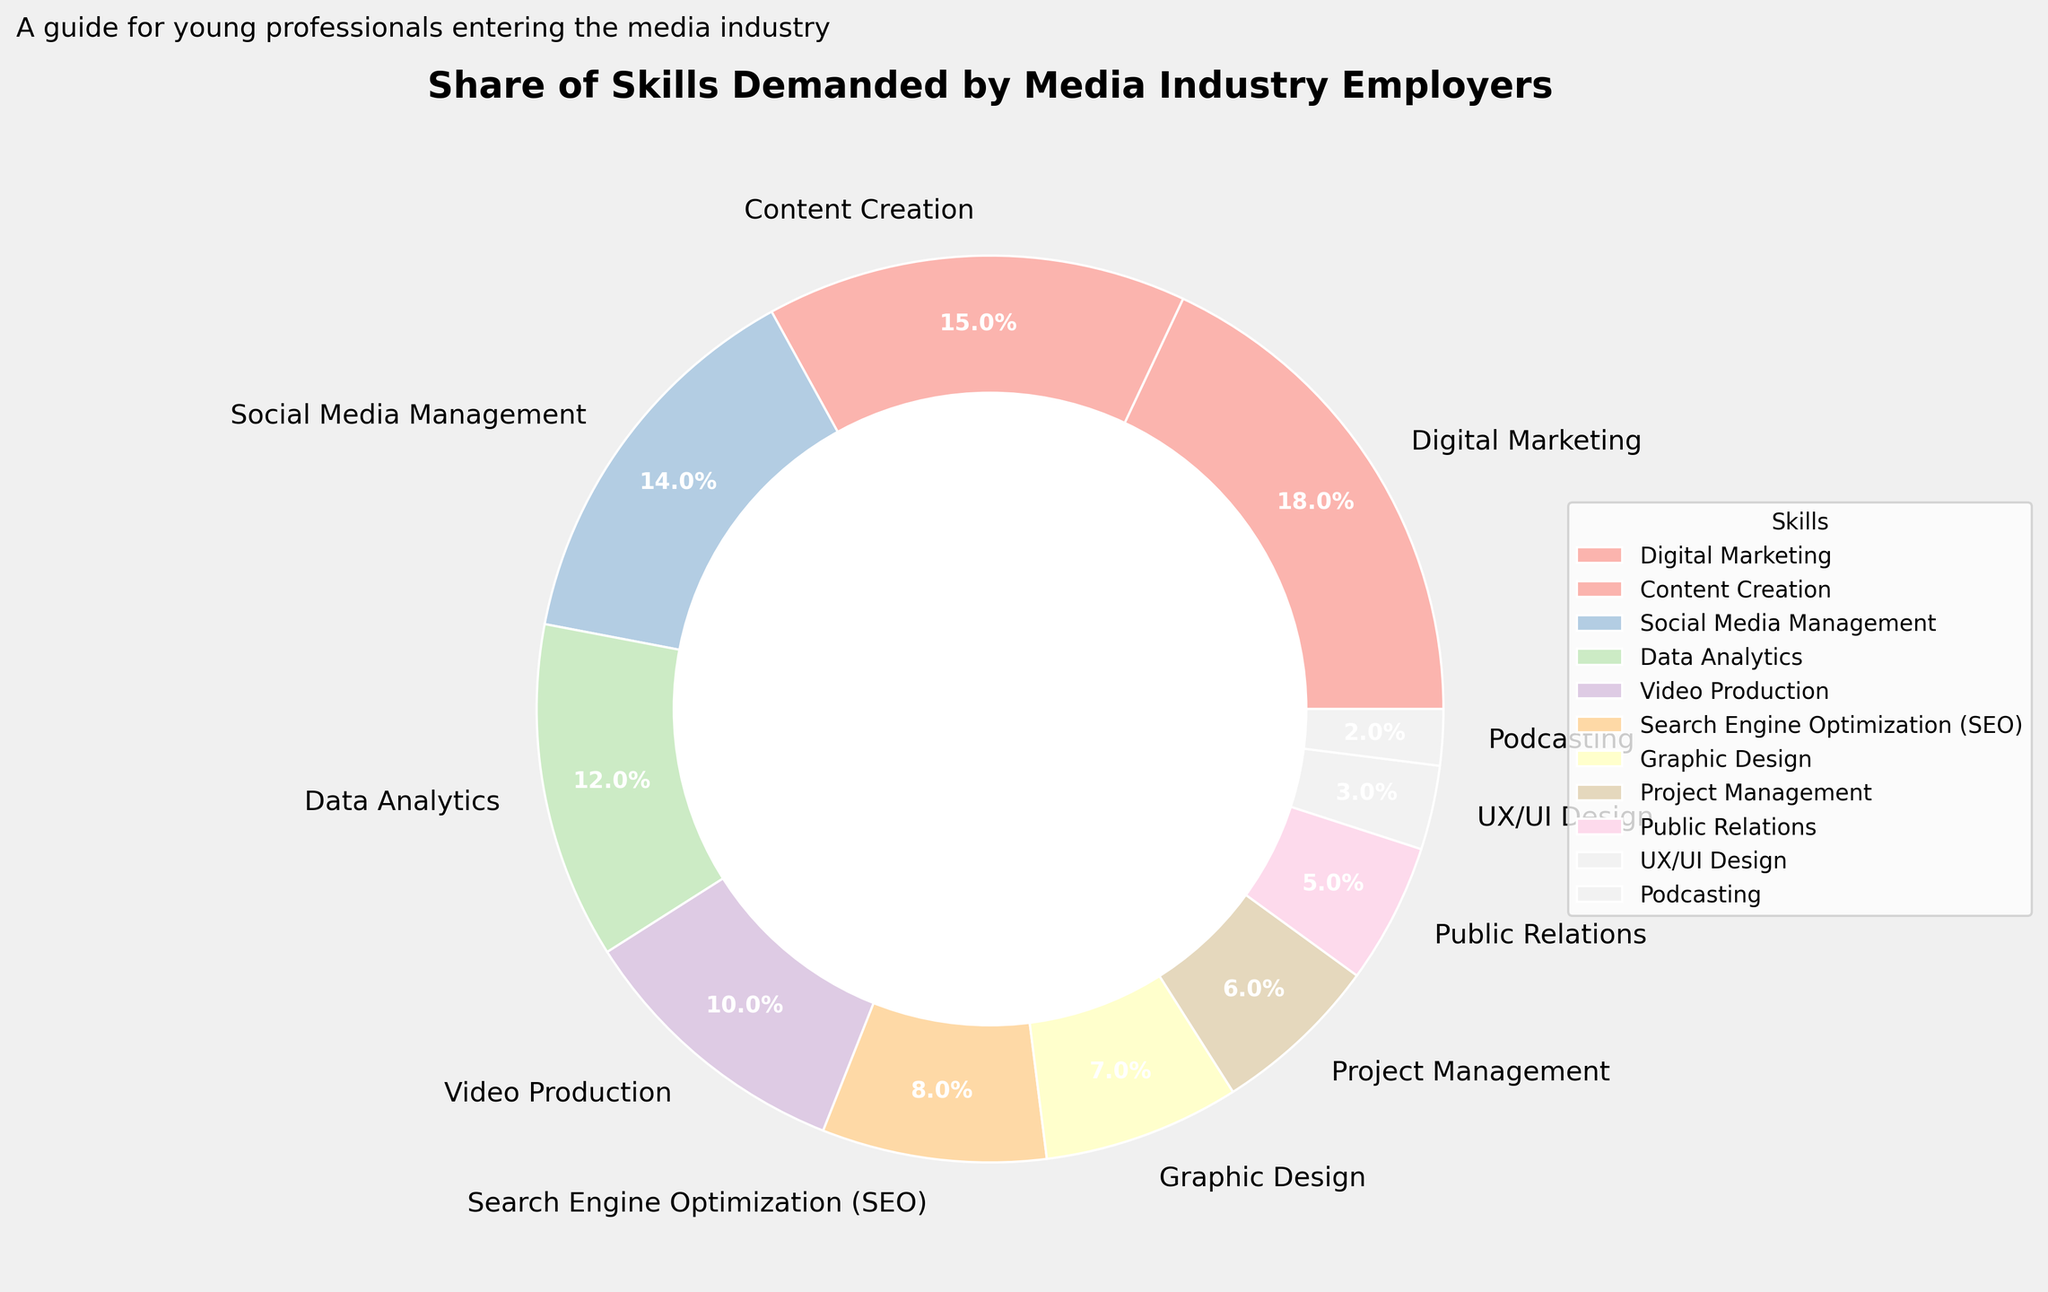What is the largest skill set demanded by media industry employers? The largest segment in the pie chart represents Digital Marketing which occupies the highest percentage among all skill sets.
Answer: Digital Marketing Which skill set has the smallest share according to the pie chart? The smallest slice of the pie chart corresponds to Podcasting, which has the lowest percentage among the listed skill sets.
Answer: Podcasting Compare the demand for Social Media Management and SEO. Which one is more in demand? By examining the pie chart, Social Media Management has a larger segment than Search Engine Optimization (SEO), indicating a higher demand.
Answer: Social Media Management What is the combined percentage of Content Creation and Video Production? The percentage for Content Creation is 15%, and for Video Production, it is 10%. Adding these together, the combined percentage is 25%.
Answer: 25% How much greater is the demand for Data Analytics compared to UX/UI Design? The demand for Data Analytics is 12%, and for UX/UI Design, it is 3%. Subtracting these values, Data Analytics is 9% more in demand than UX/UI Design.
Answer: 9% Is Graphic Design in higher demand than Public Relations based on the chart? By looking at the pie chart, Graphic Design covers a larger percentage area (7%) compared to Public Relations (5%).
Answer: Yes What is the aggregate demand for the top three skills? The top three skills by percentage are Digital Marketing (18%), Content Creation (15%), and Social Media Management (14%). Summing these gives an aggregate demand of 47%.
Answer: 47% How does the demand for Project Management compare to the demand for UX/UI Design and Public Relations combined? Project Management has a demand of 6%. UX/UI Design and Public Relations combined have a demand of (3% + 5% = 8%). Therefore, the combined demand for UX/UI Design and Public Relations is greater by 2%.
Answer: Combined demand for UX/UI Design and Public Relations is greater Which skills together make up exactly one-third of the total demand? Digital Marketing (18%) and Video Production (10%) together make up 28%. Including Public Relations (5%) sums to 33%. Therefore, these three skill sets together make up one-third (33%) of the total demand.
Answer: Digital Marketing, Video Production, Public Relations If the demand for UX/UI Design and Podcasting doubled, what would their new combined percentage be? Currently, UX/UI Design is 3%, and Podcasting is 2%. If doubled, UX/UI Design would be 6%, and Podcasting would be 4%, making a new combined total of 10%.
Answer: 10% 